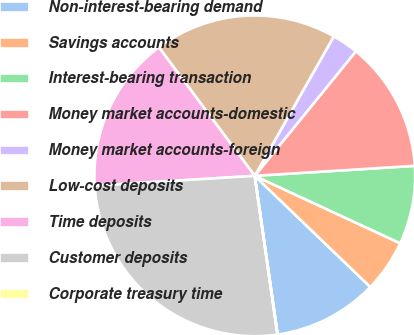<chart> <loc_0><loc_0><loc_500><loc_500><pie_chart><fcel>Non-interest-bearing demand<fcel>Savings accounts<fcel>Interest-bearing transaction<fcel>Money market accounts-domestic<fcel>Money market accounts-foreign<fcel>Low-cost deposits<fcel>Time deposits<fcel>Customer deposits<fcel>Corporate treasury time<nl><fcel>10.53%<fcel>5.28%<fcel>7.9%<fcel>13.15%<fcel>2.65%<fcel>18.41%<fcel>15.78%<fcel>26.28%<fcel>0.02%<nl></chart> 